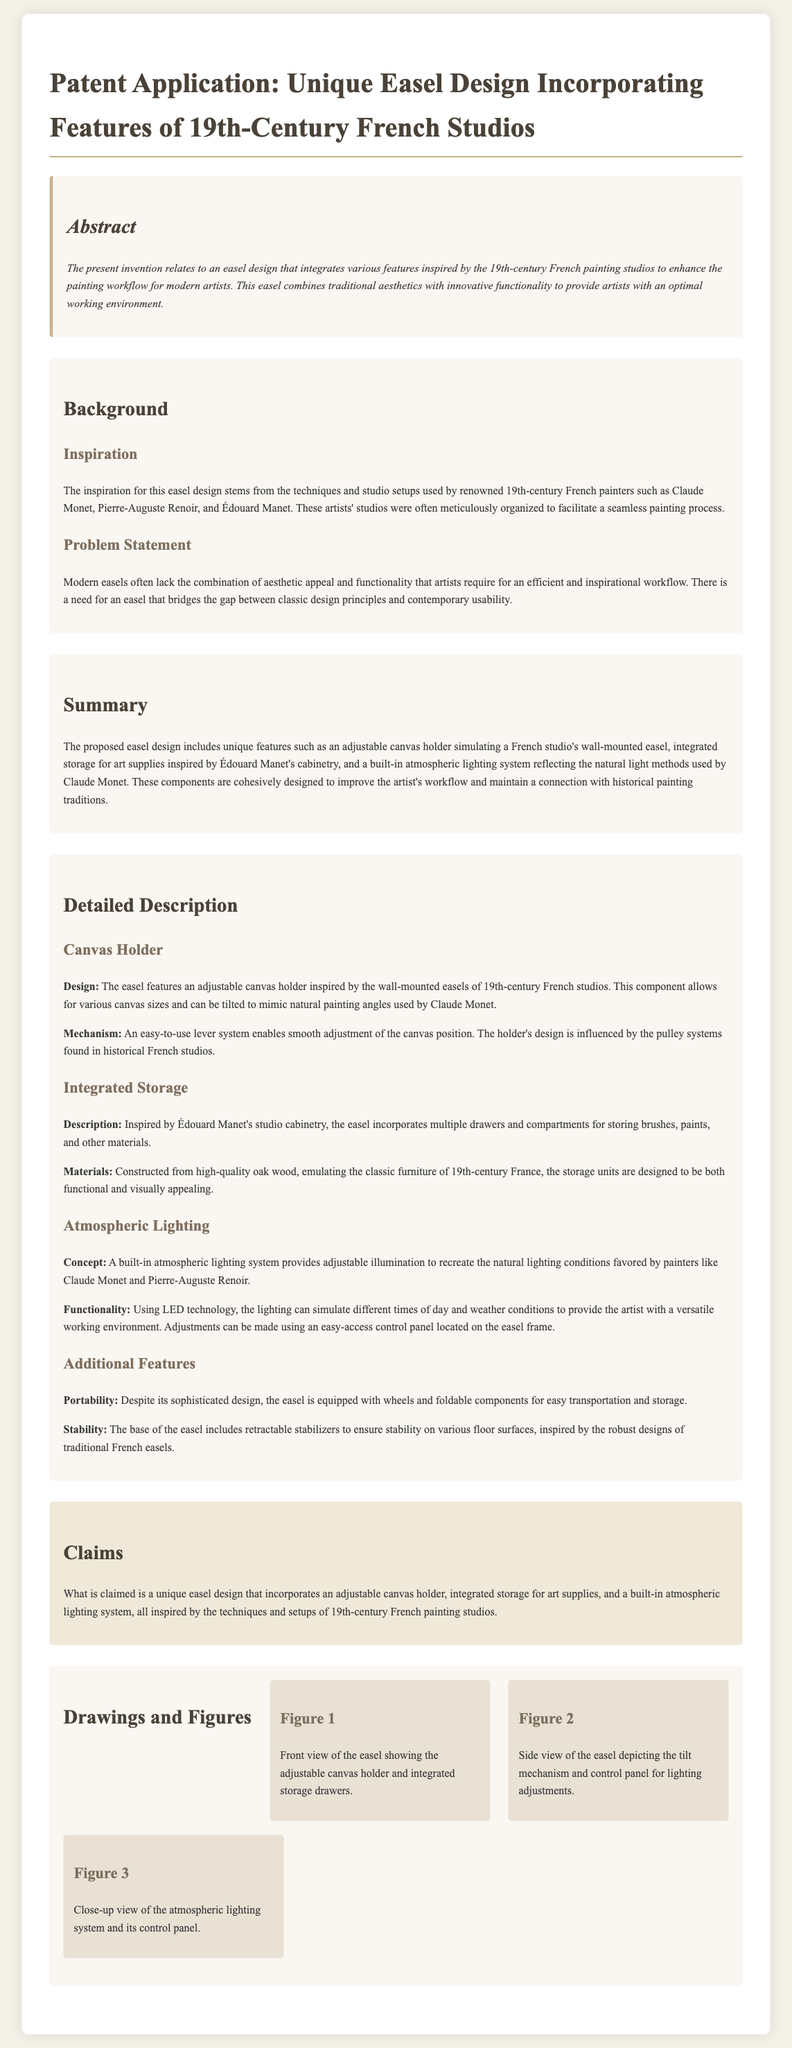What does the invention relate to? The invention relates to an easel design that integrates various features inspired by the 19th-century French painting studios to enhance the painting workflow for modern artists.
Answer: Easel design Who are the artists mentioned as inspiration? The artists mentioned as inspiration for the easel design include Claude Monet, Pierre-Auguste Renoir, and Édouard Manet.
Answer: Claude Monet, Pierre-Auguste Renoir, Édouard Manet What unique feature simulates a French studio's wall-mounted easel? The unique feature that simulates a French studio's wall-mounted easel is the adjustable canvas holder.
Answer: Adjustable canvas holder What material is used for the integrated storage? The integrated storage is constructed from high-quality oak wood.
Answer: Oak wood What technology is used for the built-in atmospheric lighting? The built-in atmospheric lighting system uses LED technology.
Answer: LED technology What best describes the type of claim made in the document? The type of claim made in the document is a unique easel design incorporating several specific features.
Answer: Unique easel design How many figures are included in the drawings and figures section? There are three figures included in the drawings and figures section.
Answer: Three figures What adjustable feature allows various canvas sizes? The adjustable canvas holder allows for various canvas sizes.
Answer: Adjustable canvas holder What enhances the easel's portability? The easel's portability is enhanced by wheels and foldable components.
Answer: Wheels and foldable components 